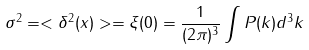<formula> <loc_0><loc_0><loc_500><loc_500>\sigma ^ { 2 } = < \delta ^ { 2 } ( x ) > = \xi ( 0 ) = \frac { 1 } { ( 2 \pi ) ^ { 3 } } \int P ( k ) d ^ { 3 } k</formula> 